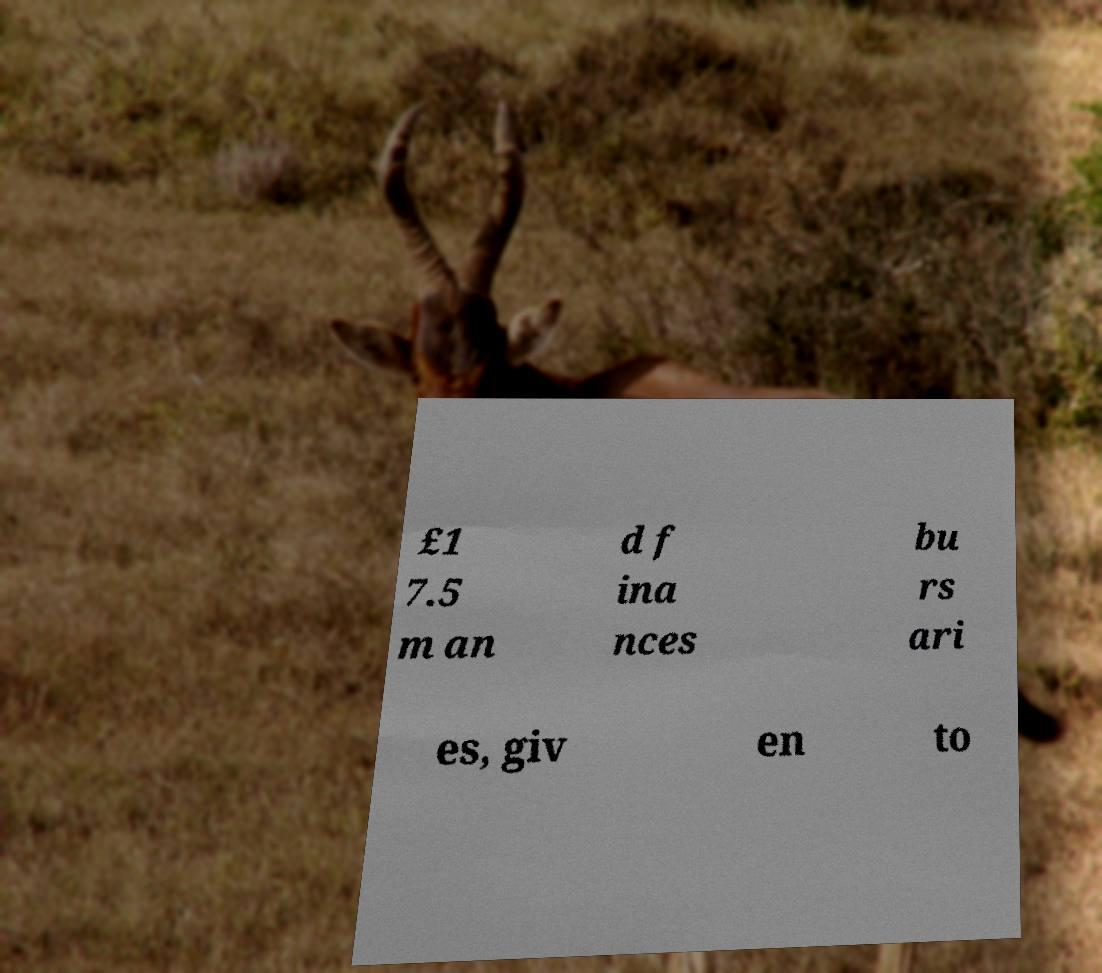There's text embedded in this image that I need extracted. Can you transcribe it verbatim? £1 7.5 m an d f ina nces bu rs ari es, giv en to 